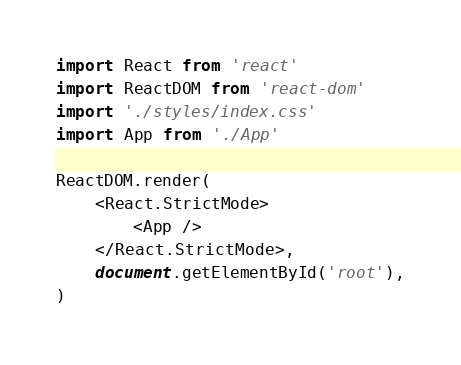Convert code to text. <code><loc_0><loc_0><loc_500><loc_500><_JavaScript_>import React from 'react'
import ReactDOM from 'react-dom'
import './styles/index.css'
import App from './App'

ReactDOM.render(
	<React.StrictMode>
		<App />
	</React.StrictMode>,
	document.getElementById('root'),
)
</code> 